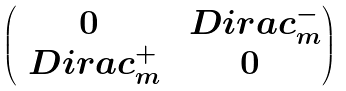<formula> <loc_0><loc_0><loc_500><loc_500>\begin{pmatrix} 0 & \ D i r a c ^ { - } _ { m } \\ \ D i r a c ^ { + } _ { m } & 0 \end{pmatrix}</formula> 